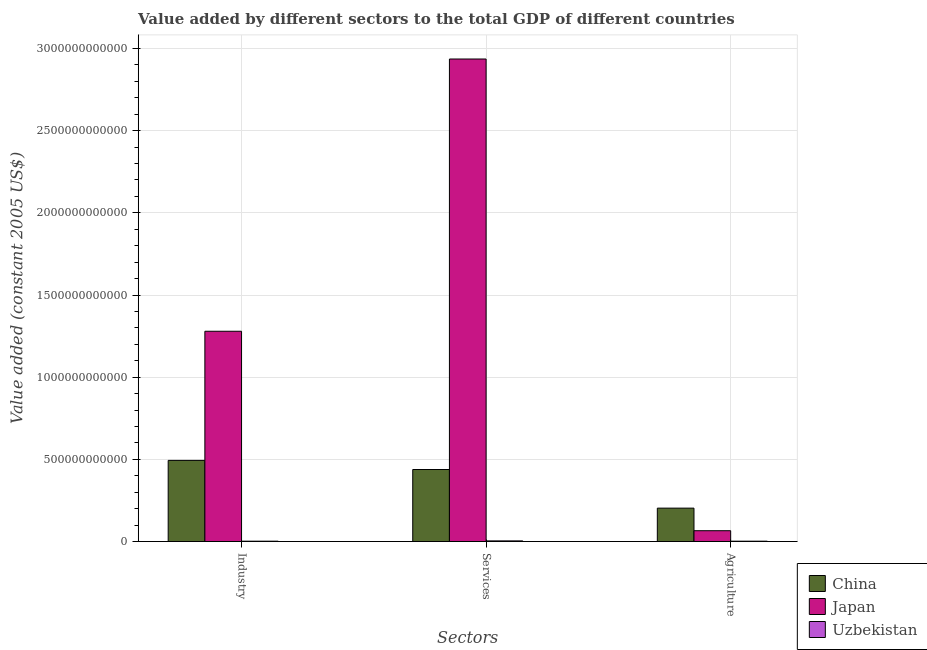Are the number of bars per tick equal to the number of legend labels?
Make the answer very short. Yes. Are the number of bars on each tick of the X-axis equal?
Ensure brevity in your answer.  Yes. What is the label of the 3rd group of bars from the left?
Offer a very short reply. Agriculture. What is the value added by industrial sector in China?
Offer a terse response. 4.94e+11. Across all countries, what is the maximum value added by services?
Keep it short and to the point. 2.94e+12. Across all countries, what is the minimum value added by agricultural sector?
Offer a very short reply. 2.29e+09. In which country was the value added by agricultural sector minimum?
Provide a succinct answer. Uzbekistan. What is the total value added by industrial sector in the graph?
Make the answer very short. 1.78e+12. What is the difference between the value added by services in Japan and that in Uzbekistan?
Your response must be concise. 2.93e+12. What is the difference between the value added by agricultural sector in China and the value added by services in Japan?
Your answer should be compact. -2.73e+12. What is the average value added by agricultural sector per country?
Ensure brevity in your answer.  9.06e+1. What is the difference between the value added by agricultural sector and value added by industrial sector in Japan?
Provide a succinct answer. -1.21e+12. What is the ratio of the value added by agricultural sector in Japan to that in China?
Your answer should be compact. 0.32. Is the difference between the value added by industrial sector in Japan and China greater than the difference between the value added by agricultural sector in Japan and China?
Provide a succinct answer. Yes. What is the difference between the highest and the second highest value added by industrial sector?
Ensure brevity in your answer.  7.86e+11. What is the difference between the highest and the lowest value added by agricultural sector?
Your answer should be compact. 2.01e+11. What does the 2nd bar from the right in Services represents?
Provide a short and direct response. Japan. How many bars are there?
Your answer should be compact. 9. How many countries are there in the graph?
Give a very brief answer. 3. What is the difference between two consecutive major ticks on the Y-axis?
Offer a very short reply. 5.00e+11. Are the values on the major ticks of Y-axis written in scientific E-notation?
Ensure brevity in your answer.  No. Does the graph contain grids?
Your answer should be very brief. Yes. Where does the legend appear in the graph?
Give a very brief answer. Bottom right. How many legend labels are there?
Your response must be concise. 3. What is the title of the graph?
Your response must be concise. Value added by different sectors to the total GDP of different countries. What is the label or title of the X-axis?
Give a very brief answer. Sectors. What is the label or title of the Y-axis?
Give a very brief answer. Value added (constant 2005 US$). What is the Value added (constant 2005 US$) of China in Industry?
Ensure brevity in your answer.  4.94e+11. What is the Value added (constant 2005 US$) of Japan in Industry?
Give a very brief answer. 1.28e+12. What is the Value added (constant 2005 US$) of Uzbekistan in Industry?
Ensure brevity in your answer.  2.30e+09. What is the Value added (constant 2005 US$) of China in Services?
Make the answer very short. 4.38e+11. What is the Value added (constant 2005 US$) of Japan in Services?
Offer a very short reply. 2.94e+12. What is the Value added (constant 2005 US$) in Uzbekistan in Services?
Make the answer very short. 4.12e+09. What is the Value added (constant 2005 US$) in China in Agriculture?
Ensure brevity in your answer.  2.03e+11. What is the Value added (constant 2005 US$) of Japan in Agriculture?
Provide a short and direct response. 6.60e+1. What is the Value added (constant 2005 US$) in Uzbekistan in Agriculture?
Give a very brief answer. 2.29e+09. Across all Sectors, what is the maximum Value added (constant 2005 US$) in China?
Provide a succinct answer. 4.94e+11. Across all Sectors, what is the maximum Value added (constant 2005 US$) in Japan?
Provide a succinct answer. 2.94e+12. Across all Sectors, what is the maximum Value added (constant 2005 US$) of Uzbekistan?
Provide a short and direct response. 4.12e+09. Across all Sectors, what is the minimum Value added (constant 2005 US$) of China?
Your answer should be compact. 2.03e+11. Across all Sectors, what is the minimum Value added (constant 2005 US$) in Japan?
Offer a terse response. 6.60e+1. Across all Sectors, what is the minimum Value added (constant 2005 US$) of Uzbekistan?
Offer a very short reply. 2.29e+09. What is the total Value added (constant 2005 US$) of China in the graph?
Keep it short and to the point. 1.14e+12. What is the total Value added (constant 2005 US$) of Japan in the graph?
Your response must be concise. 4.28e+12. What is the total Value added (constant 2005 US$) in Uzbekistan in the graph?
Your response must be concise. 8.71e+09. What is the difference between the Value added (constant 2005 US$) of China in Industry and that in Services?
Keep it short and to the point. 5.54e+1. What is the difference between the Value added (constant 2005 US$) of Japan in Industry and that in Services?
Your response must be concise. -1.66e+12. What is the difference between the Value added (constant 2005 US$) of Uzbekistan in Industry and that in Services?
Ensure brevity in your answer.  -1.82e+09. What is the difference between the Value added (constant 2005 US$) in China in Industry and that in Agriculture?
Provide a succinct answer. 2.90e+11. What is the difference between the Value added (constant 2005 US$) of Japan in Industry and that in Agriculture?
Make the answer very short. 1.21e+12. What is the difference between the Value added (constant 2005 US$) of Uzbekistan in Industry and that in Agriculture?
Offer a terse response. 1.08e+07. What is the difference between the Value added (constant 2005 US$) in China in Services and that in Agriculture?
Provide a succinct answer. 2.35e+11. What is the difference between the Value added (constant 2005 US$) in Japan in Services and that in Agriculture?
Give a very brief answer. 2.87e+12. What is the difference between the Value added (constant 2005 US$) in Uzbekistan in Services and that in Agriculture?
Keep it short and to the point. 1.83e+09. What is the difference between the Value added (constant 2005 US$) in China in Industry and the Value added (constant 2005 US$) in Japan in Services?
Keep it short and to the point. -2.44e+12. What is the difference between the Value added (constant 2005 US$) of China in Industry and the Value added (constant 2005 US$) of Uzbekistan in Services?
Provide a succinct answer. 4.90e+11. What is the difference between the Value added (constant 2005 US$) in Japan in Industry and the Value added (constant 2005 US$) in Uzbekistan in Services?
Your answer should be very brief. 1.28e+12. What is the difference between the Value added (constant 2005 US$) in China in Industry and the Value added (constant 2005 US$) in Japan in Agriculture?
Keep it short and to the point. 4.28e+11. What is the difference between the Value added (constant 2005 US$) of China in Industry and the Value added (constant 2005 US$) of Uzbekistan in Agriculture?
Your response must be concise. 4.92e+11. What is the difference between the Value added (constant 2005 US$) of Japan in Industry and the Value added (constant 2005 US$) of Uzbekistan in Agriculture?
Offer a terse response. 1.28e+12. What is the difference between the Value added (constant 2005 US$) in China in Services and the Value added (constant 2005 US$) in Japan in Agriculture?
Give a very brief answer. 3.72e+11. What is the difference between the Value added (constant 2005 US$) in China in Services and the Value added (constant 2005 US$) in Uzbekistan in Agriculture?
Provide a succinct answer. 4.36e+11. What is the difference between the Value added (constant 2005 US$) of Japan in Services and the Value added (constant 2005 US$) of Uzbekistan in Agriculture?
Offer a very short reply. 2.93e+12. What is the average Value added (constant 2005 US$) in China per Sectors?
Provide a succinct answer. 3.79e+11. What is the average Value added (constant 2005 US$) in Japan per Sectors?
Your answer should be compact. 1.43e+12. What is the average Value added (constant 2005 US$) of Uzbekistan per Sectors?
Offer a terse response. 2.90e+09. What is the difference between the Value added (constant 2005 US$) of China and Value added (constant 2005 US$) of Japan in Industry?
Your answer should be compact. -7.86e+11. What is the difference between the Value added (constant 2005 US$) of China and Value added (constant 2005 US$) of Uzbekistan in Industry?
Give a very brief answer. 4.92e+11. What is the difference between the Value added (constant 2005 US$) in Japan and Value added (constant 2005 US$) in Uzbekistan in Industry?
Give a very brief answer. 1.28e+12. What is the difference between the Value added (constant 2005 US$) of China and Value added (constant 2005 US$) of Japan in Services?
Give a very brief answer. -2.50e+12. What is the difference between the Value added (constant 2005 US$) in China and Value added (constant 2005 US$) in Uzbekistan in Services?
Give a very brief answer. 4.34e+11. What is the difference between the Value added (constant 2005 US$) in Japan and Value added (constant 2005 US$) in Uzbekistan in Services?
Provide a short and direct response. 2.93e+12. What is the difference between the Value added (constant 2005 US$) in China and Value added (constant 2005 US$) in Japan in Agriculture?
Your response must be concise. 1.37e+11. What is the difference between the Value added (constant 2005 US$) in China and Value added (constant 2005 US$) in Uzbekistan in Agriculture?
Offer a very short reply. 2.01e+11. What is the difference between the Value added (constant 2005 US$) in Japan and Value added (constant 2005 US$) in Uzbekistan in Agriculture?
Keep it short and to the point. 6.37e+1. What is the ratio of the Value added (constant 2005 US$) in China in Industry to that in Services?
Make the answer very short. 1.13. What is the ratio of the Value added (constant 2005 US$) of Japan in Industry to that in Services?
Your answer should be compact. 0.44. What is the ratio of the Value added (constant 2005 US$) in Uzbekistan in Industry to that in Services?
Offer a terse response. 0.56. What is the ratio of the Value added (constant 2005 US$) in China in Industry to that in Agriculture?
Offer a terse response. 2.43. What is the ratio of the Value added (constant 2005 US$) in Japan in Industry to that in Agriculture?
Ensure brevity in your answer.  19.38. What is the ratio of the Value added (constant 2005 US$) in Uzbekistan in Industry to that in Agriculture?
Offer a very short reply. 1. What is the ratio of the Value added (constant 2005 US$) of China in Services to that in Agriculture?
Your answer should be very brief. 2.16. What is the ratio of the Value added (constant 2005 US$) in Japan in Services to that in Agriculture?
Keep it short and to the point. 44.46. What is the ratio of the Value added (constant 2005 US$) of Uzbekistan in Services to that in Agriculture?
Your answer should be compact. 1.8. What is the difference between the highest and the second highest Value added (constant 2005 US$) of China?
Your response must be concise. 5.54e+1. What is the difference between the highest and the second highest Value added (constant 2005 US$) in Japan?
Make the answer very short. 1.66e+12. What is the difference between the highest and the second highest Value added (constant 2005 US$) of Uzbekistan?
Offer a very short reply. 1.82e+09. What is the difference between the highest and the lowest Value added (constant 2005 US$) of China?
Keep it short and to the point. 2.90e+11. What is the difference between the highest and the lowest Value added (constant 2005 US$) of Japan?
Your response must be concise. 2.87e+12. What is the difference between the highest and the lowest Value added (constant 2005 US$) of Uzbekistan?
Offer a very short reply. 1.83e+09. 